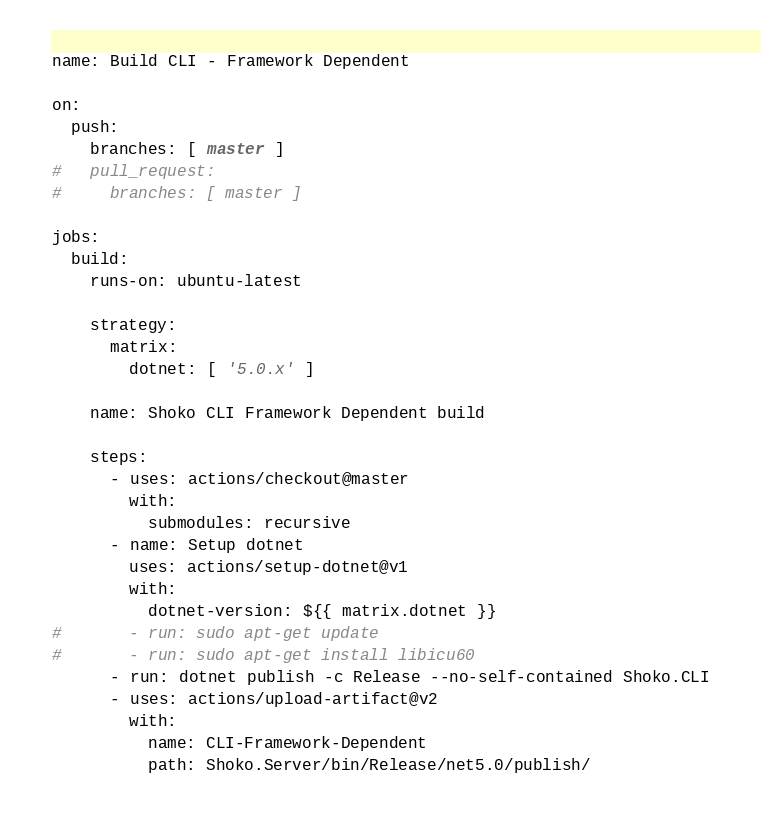Convert code to text. <code><loc_0><loc_0><loc_500><loc_500><_YAML_>name: Build CLI - Framework Dependent

on:
  push:
    branches: [ master ]
#   pull_request:
#     branches: [ master ]

jobs:
  build:
    runs-on: ubuntu-latest

    strategy:
      matrix:
        dotnet: [ '5.0.x' ]

    name: Shoko CLI Framework Dependent build

    steps:
      - uses: actions/checkout@master
        with:
          submodules: recursive
      - name: Setup dotnet
        uses: actions/setup-dotnet@v1
        with:
          dotnet-version: ${{ matrix.dotnet }}
#       - run: sudo apt-get update
#       - run: sudo apt-get install libicu60
      - run: dotnet publish -c Release --no-self-contained Shoko.CLI
      - uses: actions/upload-artifact@v2
        with:
          name: CLI-Framework-Dependent
          path: Shoko.Server/bin/Release/net5.0/publish/
</code> 